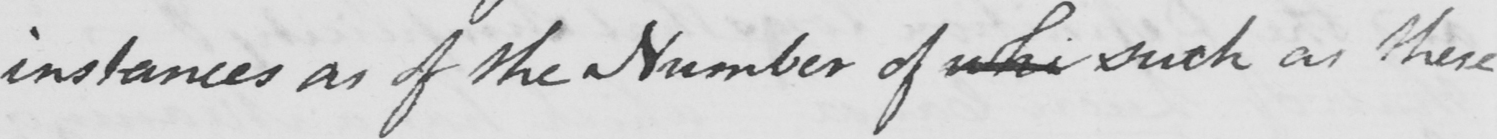Can you read and transcribe this handwriting? instances as the Number of whi such as these 